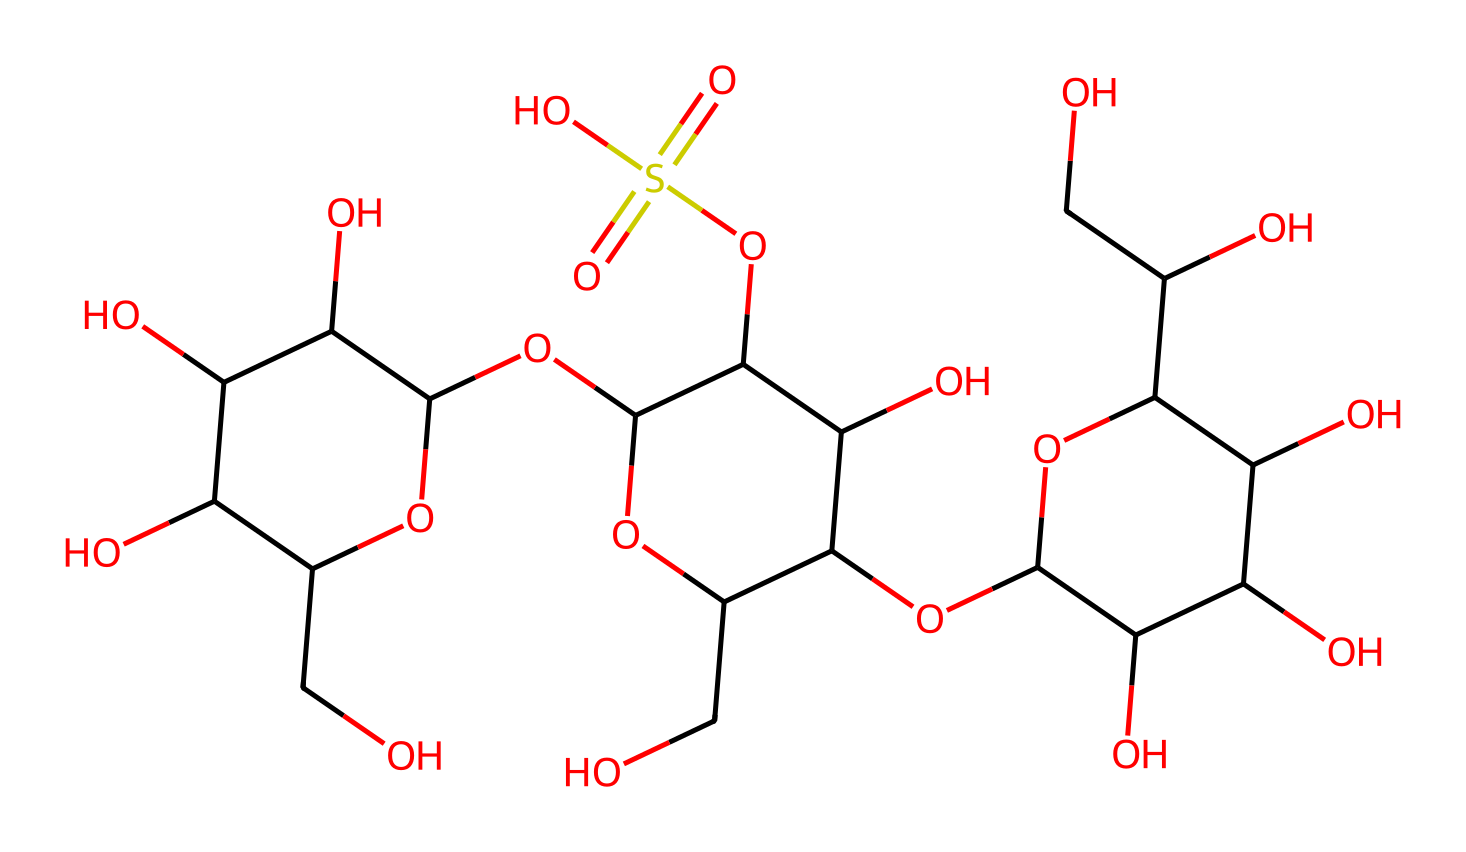What is the primary function of carrageenan in food? Carrageenan is primarily used as a thickening and gelling agent in various food products, helping to improve texture and stability.
Answer: thickening agent How many sulfur atoms are present in the structure? By analyzing the SMILES representation, we can count the sulfur atoms ('S'), and there are two sulfur atoms present in the structure.
Answer: two What functional group is responsible for the acidity in carrageenan? The -SO3H group (sulfonic acid) contributes to the acidity of carrageenan, indicated by the presence of 'S(=O)(=O)O' in the structure.
Answer: sulfonic acid What type of polysaccharide is carrageenan classified as? Carrageenan is classified as a linear polysaccharide, consisting of repeating units derived from galactose sugars, as evidenced by its structure containing multiple sugar units.
Answer: linear polysaccharide How many rings are indicated in the structure of carrageenan? By checking the structural representation, we can identify that there are multiple cyclic sections, indicating three distinct rings in the structure.
Answer: three 